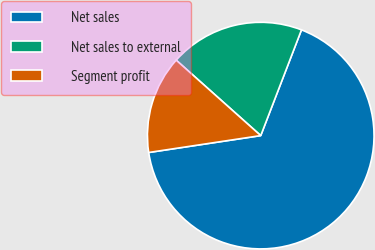Convert chart to OTSL. <chart><loc_0><loc_0><loc_500><loc_500><pie_chart><fcel>Net sales<fcel>Net sales to external<fcel>Segment profit<nl><fcel>66.77%<fcel>19.26%<fcel>13.98%<nl></chart> 